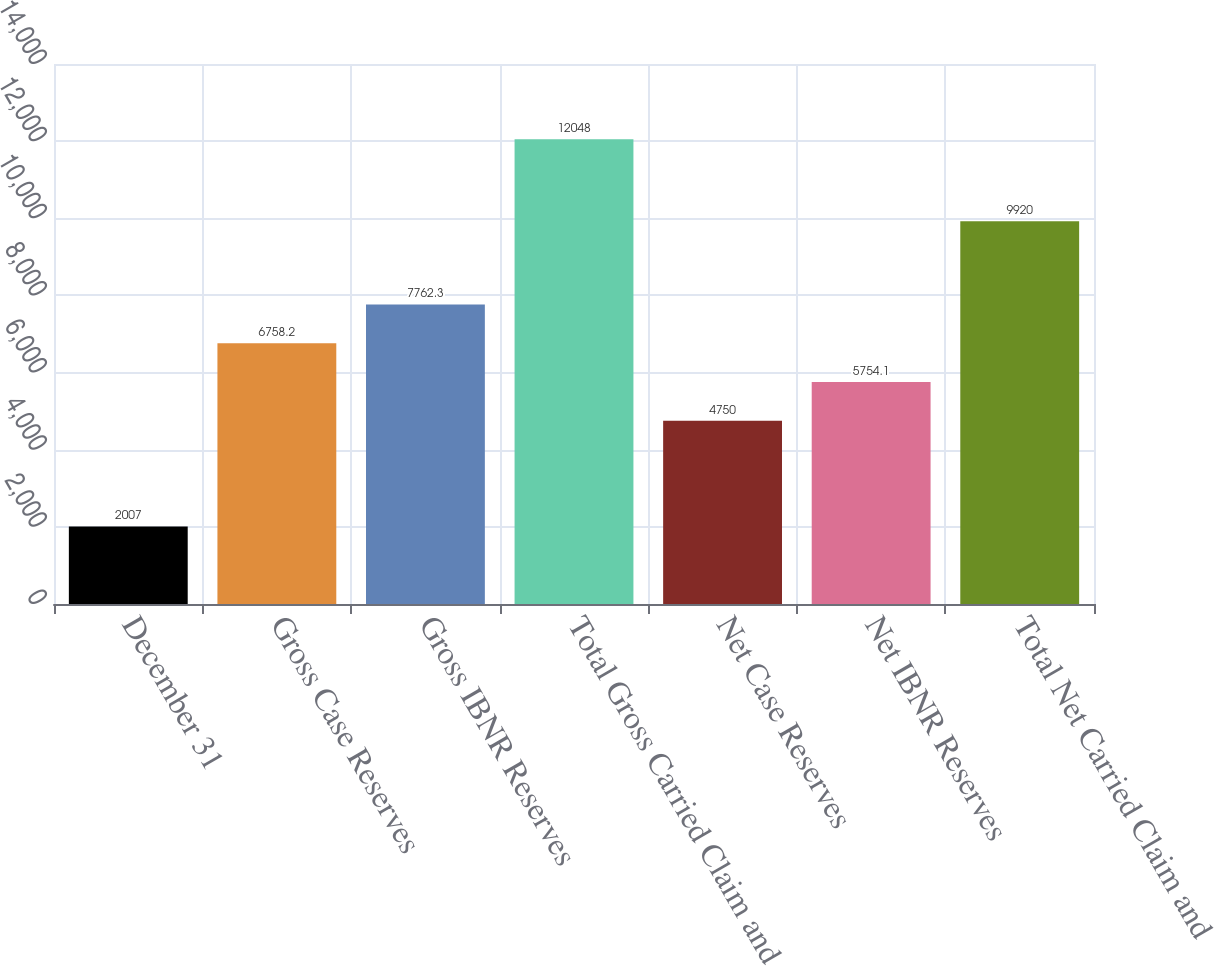<chart> <loc_0><loc_0><loc_500><loc_500><bar_chart><fcel>December 31<fcel>Gross Case Reserves<fcel>Gross IBNR Reserves<fcel>Total Gross Carried Claim and<fcel>Net Case Reserves<fcel>Net IBNR Reserves<fcel>Total Net Carried Claim and<nl><fcel>2007<fcel>6758.2<fcel>7762.3<fcel>12048<fcel>4750<fcel>5754.1<fcel>9920<nl></chart> 